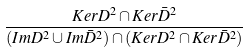Convert formula to latex. <formula><loc_0><loc_0><loc_500><loc_500>\frac { K e r D ^ { 2 } \cap K e r \bar { D } ^ { 2 } } { ( I m D ^ { 2 } \cup I m \bar { D } ^ { 2 } ) \cap ( K e r D ^ { 2 } \cap K e r \bar { D } ^ { 2 } ) }</formula> 